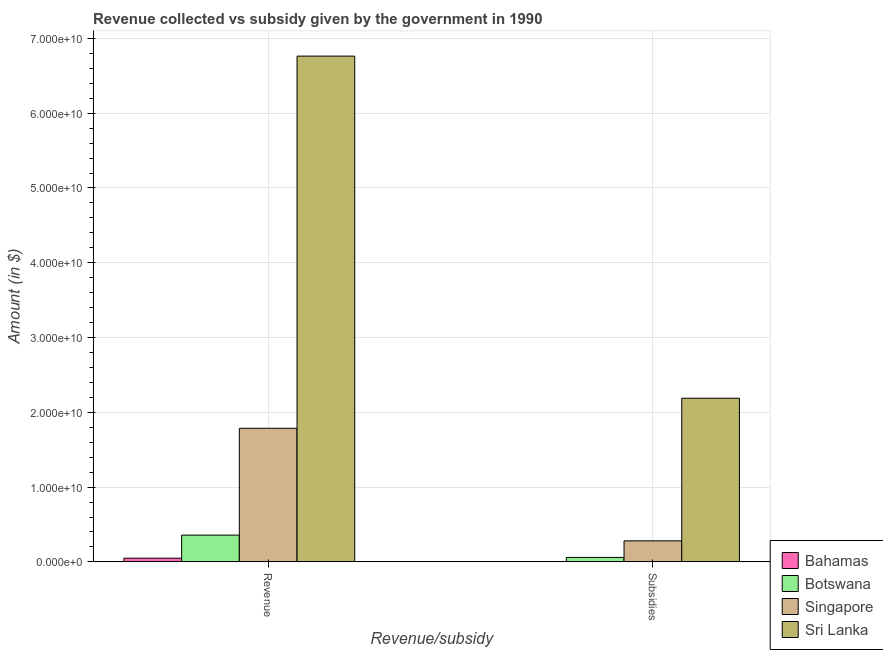How many different coloured bars are there?
Ensure brevity in your answer.  4. How many groups of bars are there?
Give a very brief answer. 2. How many bars are there on the 1st tick from the left?
Offer a terse response. 4. What is the label of the 1st group of bars from the left?
Offer a terse response. Revenue. What is the amount of subsidies given in Singapore?
Your answer should be very brief. 2.82e+09. Across all countries, what is the maximum amount of subsidies given?
Your answer should be compact. 2.19e+1. Across all countries, what is the minimum amount of subsidies given?
Make the answer very short. 3.22e+07. In which country was the amount of revenue collected maximum?
Your answer should be very brief. Sri Lanka. In which country was the amount of subsidies given minimum?
Provide a succinct answer. Bahamas. What is the total amount of revenue collected in the graph?
Make the answer very short. 8.96e+1. What is the difference between the amount of revenue collected in Bahamas and that in Sri Lanka?
Your answer should be very brief. -6.71e+1. What is the difference between the amount of revenue collected in Sri Lanka and the amount of subsidies given in Botswana?
Your response must be concise. 6.70e+1. What is the average amount of subsidies given per country?
Ensure brevity in your answer.  6.33e+09. What is the difference between the amount of subsidies given and amount of revenue collected in Botswana?
Your answer should be very brief. -2.98e+09. What is the ratio of the amount of subsidies given in Bahamas to that in Botswana?
Offer a very short reply. 0.05. Is the amount of subsidies given in Botswana less than that in Singapore?
Your response must be concise. Yes. In how many countries, is the amount of subsidies given greater than the average amount of subsidies given taken over all countries?
Your answer should be compact. 1. What does the 3rd bar from the left in Subsidies represents?
Ensure brevity in your answer.  Singapore. What does the 3rd bar from the right in Revenue represents?
Provide a succinct answer. Botswana. Are all the bars in the graph horizontal?
Give a very brief answer. No. How many countries are there in the graph?
Your response must be concise. 4. How many legend labels are there?
Offer a terse response. 4. What is the title of the graph?
Provide a short and direct response. Revenue collected vs subsidy given by the government in 1990. What is the label or title of the X-axis?
Offer a terse response. Revenue/subsidy. What is the label or title of the Y-axis?
Give a very brief answer. Amount (in $). What is the Amount (in $) in Bahamas in Revenue?
Your answer should be compact. 4.98e+08. What is the Amount (in $) in Botswana in Revenue?
Provide a succinct answer. 3.58e+09. What is the Amount (in $) of Singapore in Revenue?
Your answer should be very brief. 1.79e+1. What is the Amount (in $) in Sri Lanka in Revenue?
Your response must be concise. 6.76e+1. What is the Amount (in $) in Bahamas in Subsidies?
Make the answer very short. 3.22e+07. What is the Amount (in $) of Botswana in Subsidies?
Ensure brevity in your answer.  5.99e+08. What is the Amount (in $) in Singapore in Subsidies?
Your response must be concise. 2.82e+09. What is the Amount (in $) in Sri Lanka in Subsidies?
Keep it short and to the point. 2.19e+1. Across all Revenue/subsidy, what is the maximum Amount (in $) of Bahamas?
Provide a succinct answer. 4.98e+08. Across all Revenue/subsidy, what is the maximum Amount (in $) of Botswana?
Your response must be concise. 3.58e+09. Across all Revenue/subsidy, what is the maximum Amount (in $) of Singapore?
Offer a very short reply. 1.79e+1. Across all Revenue/subsidy, what is the maximum Amount (in $) of Sri Lanka?
Give a very brief answer. 6.76e+1. Across all Revenue/subsidy, what is the minimum Amount (in $) in Bahamas?
Offer a terse response. 3.22e+07. Across all Revenue/subsidy, what is the minimum Amount (in $) in Botswana?
Make the answer very short. 5.99e+08. Across all Revenue/subsidy, what is the minimum Amount (in $) in Singapore?
Give a very brief answer. 2.82e+09. Across all Revenue/subsidy, what is the minimum Amount (in $) in Sri Lanka?
Ensure brevity in your answer.  2.19e+1. What is the total Amount (in $) in Bahamas in the graph?
Your answer should be compact. 5.30e+08. What is the total Amount (in $) in Botswana in the graph?
Your response must be concise. 4.18e+09. What is the total Amount (in $) of Singapore in the graph?
Ensure brevity in your answer.  2.07e+1. What is the total Amount (in $) of Sri Lanka in the graph?
Ensure brevity in your answer.  8.95e+1. What is the difference between the Amount (in $) in Bahamas in Revenue and that in Subsidies?
Ensure brevity in your answer.  4.66e+08. What is the difference between the Amount (in $) in Botswana in Revenue and that in Subsidies?
Keep it short and to the point. 2.98e+09. What is the difference between the Amount (in $) in Singapore in Revenue and that in Subsidies?
Your answer should be compact. 1.51e+1. What is the difference between the Amount (in $) of Sri Lanka in Revenue and that in Subsidies?
Your answer should be very brief. 4.57e+1. What is the difference between the Amount (in $) of Bahamas in Revenue and the Amount (in $) of Botswana in Subsidies?
Your response must be concise. -1.01e+08. What is the difference between the Amount (in $) in Bahamas in Revenue and the Amount (in $) in Singapore in Subsidies?
Give a very brief answer. -2.32e+09. What is the difference between the Amount (in $) in Bahamas in Revenue and the Amount (in $) in Sri Lanka in Subsidies?
Your response must be concise. -2.14e+1. What is the difference between the Amount (in $) of Botswana in Revenue and the Amount (in $) of Singapore in Subsidies?
Your response must be concise. 7.66e+08. What is the difference between the Amount (in $) of Botswana in Revenue and the Amount (in $) of Sri Lanka in Subsidies?
Keep it short and to the point. -1.83e+1. What is the difference between the Amount (in $) of Singapore in Revenue and the Amount (in $) of Sri Lanka in Subsidies?
Your answer should be compact. -4.02e+09. What is the average Amount (in $) of Bahamas per Revenue/subsidy?
Your answer should be compact. 2.65e+08. What is the average Amount (in $) of Botswana per Revenue/subsidy?
Provide a succinct answer. 2.09e+09. What is the average Amount (in $) of Singapore per Revenue/subsidy?
Provide a short and direct response. 1.03e+1. What is the average Amount (in $) of Sri Lanka per Revenue/subsidy?
Offer a terse response. 4.48e+1. What is the difference between the Amount (in $) of Bahamas and Amount (in $) of Botswana in Revenue?
Your response must be concise. -3.08e+09. What is the difference between the Amount (in $) of Bahamas and Amount (in $) of Singapore in Revenue?
Offer a very short reply. -1.74e+1. What is the difference between the Amount (in $) in Bahamas and Amount (in $) in Sri Lanka in Revenue?
Offer a very short reply. -6.71e+1. What is the difference between the Amount (in $) in Botswana and Amount (in $) in Singapore in Revenue?
Your answer should be compact. -1.43e+1. What is the difference between the Amount (in $) of Botswana and Amount (in $) of Sri Lanka in Revenue?
Make the answer very short. -6.41e+1. What is the difference between the Amount (in $) of Singapore and Amount (in $) of Sri Lanka in Revenue?
Make the answer very short. -4.98e+1. What is the difference between the Amount (in $) of Bahamas and Amount (in $) of Botswana in Subsidies?
Keep it short and to the point. -5.67e+08. What is the difference between the Amount (in $) in Bahamas and Amount (in $) in Singapore in Subsidies?
Give a very brief answer. -2.78e+09. What is the difference between the Amount (in $) of Bahamas and Amount (in $) of Sri Lanka in Subsidies?
Make the answer very short. -2.19e+1. What is the difference between the Amount (in $) in Botswana and Amount (in $) in Singapore in Subsidies?
Provide a short and direct response. -2.22e+09. What is the difference between the Amount (in $) of Botswana and Amount (in $) of Sri Lanka in Subsidies?
Your answer should be compact. -2.13e+1. What is the difference between the Amount (in $) of Singapore and Amount (in $) of Sri Lanka in Subsidies?
Offer a very short reply. -1.91e+1. What is the ratio of the Amount (in $) in Bahamas in Revenue to that in Subsidies?
Provide a succinct answer. 15.48. What is the ratio of the Amount (in $) in Botswana in Revenue to that in Subsidies?
Make the answer very short. 5.98. What is the ratio of the Amount (in $) in Singapore in Revenue to that in Subsidies?
Offer a very short reply. 6.35. What is the ratio of the Amount (in $) in Sri Lanka in Revenue to that in Subsidies?
Make the answer very short. 3.09. What is the difference between the highest and the second highest Amount (in $) in Bahamas?
Offer a very short reply. 4.66e+08. What is the difference between the highest and the second highest Amount (in $) in Botswana?
Make the answer very short. 2.98e+09. What is the difference between the highest and the second highest Amount (in $) in Singapore?
Keep it short and to the point. 1.51e+1. What is the difference between the highest and the second highest Amount (in $) in Sri Lanka?
Make the answer very short. 4.57e+1. What is the difference between the highest and the lowest Amount (in $) of Bahamas?
Your response must be concise. 4.66e+08. What is the difference between the highest and the lowest Amount (in $) of Botswana?
Offer a very short reply. 2.98e+09. What is the difference between the highest and the lowest Amount (in $) of Singapore?
Offer a terse response. 1.51e+1. What is the difference between the highest and the lowest Amount (in $) in Sri Lanka?
Give a very brief answer. 4.57e+1. 